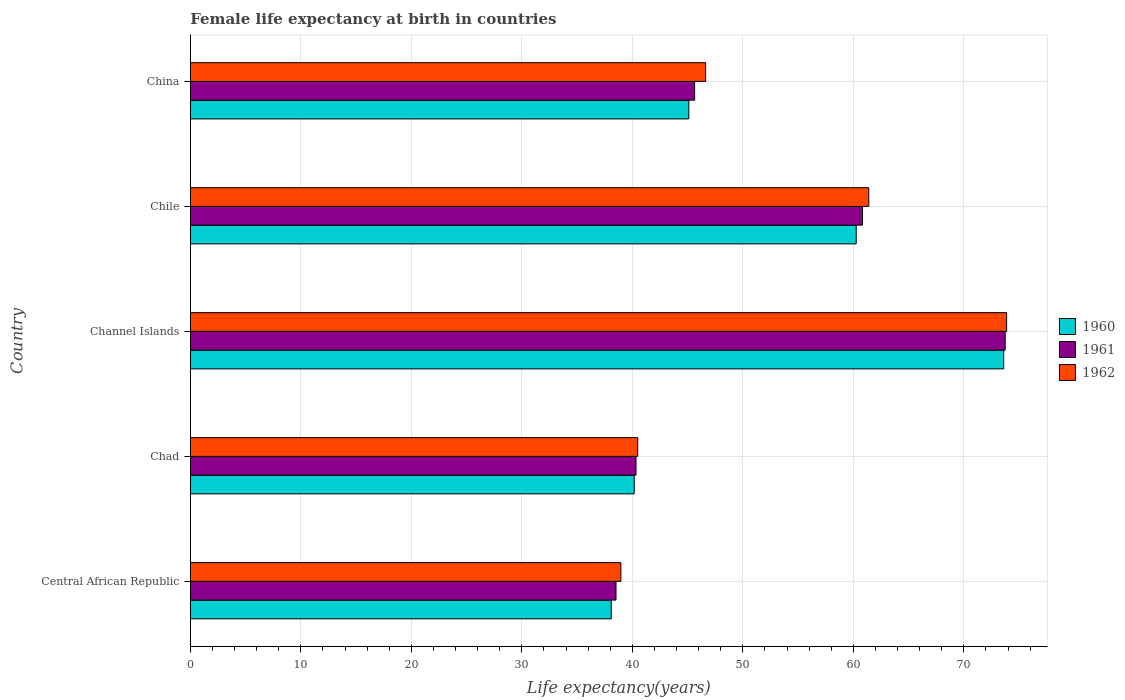How many groups of bars are there?
Your response must be concise. 5. Are the number of bars per tick equal to the number of legend labels?
Provide a short and direct response. Yes. What is the label of the 5th group of bars from the top?
Your answer should be very brief. Central African Republic. In how many cases, is the number of bars for a given country not equal to the number of legend labels?
Offer a terse response. 0. What is the female life expectancy at birth in 1961 in China?
Keep it short and to the point. 45.64. Across all countries, what is the maximum female life expectancy at birth in 1960?
Your response must be concise. 73.61. Across all countries, what is the minimum female life expectancy at birth in 1962?
Your answer should be compact. 38.97. In which country was the female life expectancy at birth in 1961 maximum?
Keep it short and to the point. Channel Islands. In which country was the female life expectancy at birth in 1961 minimum?
Make the answer very short. Central African Republic. What is the total female life expectancy at birth in 1961 in the graph?
Your response must be concise. 259.07. What is the difference between the female life expectancy at birth in 1962 in Chad and that in Chile?
Give a very brief answer. -20.91. What is the difference between the female life expectancy at birth in 1962 in China and the female life expectancy at birth in 1960 in Channel Islands?
Keep it short and to the point. -26.97. What is the average female life expectancy at birth in 1961 per country?
Offer a terse response. 51.81. What is the difference between the female life expectancy at birth in 1962 and female life expectancy at birth in 1960 in China?
Offer a very short reply. 1.53. In how many countries, is the female life expectancy at birth in 1960 greater than 6 years?
Provide a short and direct response. 5. What is the ratio of the female life expectancy at birth in 1962 in Channel Islands to that in Chile?
Your answer should be very brief. 1.2. Is the female life expectancy at birth in 1961 in Chad less than that in China?
Your answer should be very brief. Yes. What is the difference between the highest and the second highest female life expectancy at birth in 1962?
Offer a terse response. 12.47. What is the difference between the highest and the lowest female life expectancy at birth in 1962?
Offer a very short reply. 34.91. In how many countries, is the female life expectancy at birth in 1961 greater than the average female life expectancy at birth in 1961 taken over all countries?
Give a very brief answer. 2. Is the sum of the female life expectancy at birth in 1962 in Chad and Chile greater than the maximum female life expectancy at birth in 1960 across all countries?
Provide a short and direct response. Yes. What does the 1st bar from the top in Chile represents?
Your answer should be very brief. 1962. What does the 1st bar from the bottom in China represents?
Make the answer very short. 1960. Does the graph contain grids?
Provide a succinct answer. Yes. Where does the legend appear in the graph?
Provide a short and direct response. Center right. How many legend labels are there?
Your answer should be very brief. 3. What is the title of the graph?
Keep it short and to the point. Female life expectancy at birth in countries. What is the label or title of the X-axis?
Your response must be concise. Life expectancy(years). What is the label or title of the Y-axis?
Offer a terse response. Country. What is the Life expectancy(years) of 1960 in Central African Republic?
Your answer should be very brief. 38.09. What is the Life expectancy(years) in 1961 in Central African Republic?
Ensure brevity in your answer.  38.52. What is the Life expectancy(years) in 1962 in Central African Republic?
Provide a succinct answer. 38.97. What is the Life expectancy(years) of 1960 in Chad?
Your response must be concise. 40.17. What is the Life expectancy(years) in 1961 in Chad?
Provide a short and direct response. 40.33. What is the Life expectancy(years) of 1962 in Chad?
Your response must be concise. 40.49. What is the Life expectancy(years) of 1960 in Channel Islands?
Offer a terse response. 73.61. What is the Life expectancy(years) in 1961 in Channel Islands?
Keep it short and to the point. 73.74. What is the Life expectancy(years) in 1962 in Channel Islands?
Offer a terse response. 73.87. What is the Life expectancy(years) in 1960 in Chile?
Your response must be concise. 60.26. What is the Life expectancy(years) of 1961 in Chile?
Provide a short and direct response. 60.83. What is the Life expectancy(years) in 1962 in Chile?
Keep it short and to the point. 61.4. What is the Life expectancy(years) of 1960 in China?
Keep it short and to the point. 45.11. What is the Life expectancy(years) in 1961 in China?
Keep it short and to the point. 45.64. What is the Life expectancy(years) of 1962 in China?
Provide a short and direct response. 46.64. Across all countries, what is the maximum Life expectancy(years) in 1960?
Your answer should be compact. 73.61. Across all countries, what is the maximum Life expectancy(years) of 1961?
Give a very brief answer. 73.74. Across all countries, what is the maximum Life expectancy(years) of 1962?
Ensure brevity in your answer.  73.87. Across all countries, what is the minimum Life expectancy(years) in 1960?
Make the answer very short. 38.09. Across all countries, what is the minimum Life expectancy(years) of 1961?
Offer a very short reply. 38.52. Across all countries, what is the minimum Life expectancy(years) of 1962?
Your response must be concise. 38.97. What is the total Life expectancy(years) in 1960 in the graph?
Your answer should be compact. 257.25. What is the total Life expectancy(years) of 1961 in the graph?
Keep it short and to the point. 259.07. What is the total Life expectancy(years) in 1962 in the graph?
Your answer should be compact. 261.36. What is the difference between the Life expectancy(years) of 1960 in Central African Republic and that in Chad?
Provide a short and direct response. -2.08. What is the difference between the Life expectancy(years) of 1961 in Central African Republic and that in Chad?
Your response must be concise. -1.81. What is the difference between the Life expectancy(years) of 1962 in Central African Republic and that in Chad?
Ensure brevity in your answer.  -1.52. What is the difference between the Life expectancy(years) of 1960 in Central African Republic and that in Channel Islands?
Provide a succinct answer. -35.52. What is the difference between the Life expectancy(years) in 1961 in Central African Republic and that in Channel Islands?
Ensure brevity in your answer.  -35.22. What is the difference between the Life expectancy(years) of 1962 in Central African Republic and that in Channel Islands?
Ensure brevity in your answer.  -34.91. What is the difference between the Life expectancy(years) in 1960 in Central African Republic and that in Chile?
Keep it short and to the point. -22.17. What is the difference between the Life expectancy(years) of 1961 in Central African Republic and that in Chile?
Your response must be concise. -22.3. What is the difference between the Life expectancy(years) in 1962 in Central African Republic and that in Chile?
Provide a succinct answer. -22.43. What is the difference between the Life expectancy(years) in 1960 in Central African Republic and that in China?
Provide a succinct answer. -7.02. What is the difference between the Life expectancy(years) of 1961 in Central African Republic and that in China?
Offer a terse response. -7.11. What is the difference between the Life expectancy(years) of 1962 in Central African Republic and that in China?
Make the answer very short. -7.67. What is the difference between the Life expectancy(years) of 1960 in Chad and that in Channel Islands?
Your response must be concise. -33.44. What is the difference between the Life expectancy(years) in 1961 in Chad and that in Channel Islands?
Give a very brief answer. -33.41. What is the difference between the Life expectancy(years) of 1962 in Chad and that in Channel Islands?
Ensure brevity in your answer.  -33.38. What is the difference between the Life expectancy(years) in 1960 in Chad and that in Chile?
Your answer should be compact. -20.09. What is the difference between the Life expectancy(years) in 1961 in Chad and that in Chile?
Your answer should be very brief. -20.49. What is the difference between the Life expectancy(years) of 1962 in Chad and that in Chile?
Your answer should be compact. -20.91. What is the difference between the Life expectancy(years) in 1960 in Chad and that in China?
Make the answer very short. -4.94. What is the difference between the Life expectancy(years) in 1961 in Chad and that in China?
Ensure brevity in your answer.  -5.3. What is the difference between the Life expectancy(years) of 1962 in Chad and that in China?
Offer a very short reply. -6.15. What is the difference between the Life expectancy(years) of 1960 in Channel Islands and that in Chile?
Your response must be concise. 13.35. What is the difference between the Life expectancy(years) in 1961 in Channel Islands and that in Chile?
Offer a terse response. 12.91. What is the difference between the Life expectancy(years) in 1962 in Channel Islands and that in Chile?
Your response must be concise. 12.47. What is the difference between the Life expectancy(years) in 1960 in Channel Islands and that in China?
Your response must be concise. 28.5. What is the difference between the Life expectancy(years) in 1961 in Channel Islands and that in China?
Provide a short and direct response. 28.1. What is the difference between the Life expectancy(years) in 1962 in Channel Islands and that in China?
Give a very brief answer. 27.23. What is the difference between the Life expectancy(years) in 1960 in Chile and that in China?
Offer a very short reply. 15.15. What is the difference between the Life expectancy(years) in 1961 in Chile and that in China?
Your response must be concise. 15.19. What is the difference between the Life expectancy(years) in 1962 in Chile and that in China?
Offer a very short reply. 14.76. What is the difference between the Life expectancy(years) of 1960 in Central African Republic and the Life expectancy(years) of 1961 in Chad?
Offer a terse response. -2.24. What is the difference between the Life expectancy(years) of 1960 in Central African Republic and the Life expectancy(years) of 1962 in Chad?
Provide a short and direct response. -2.39. What is the difference between the Life expectancy(years) in 1961 in Central African Republic and the Life expectancy(years) in 1962 in Chad?
Ensure brevity in your answer.  -1.96. What is the difference between the Life expectancy(years) of 1960 in Central African Republic and the Life expectancy(years) of 1961 in Channel Islands?
Your answer should be very brief. -35.65. What is the difference between the Life expectancy(years) of 1960 in Central African Republic and the Life expectancy(years) of 1962 in Channel Islands?
Give a very brief answer. -35.78. What is the difference between the Life expectancy(years) of 1961 in Central African Republic and the Life expectancy(years) of 1962 in Channel Islands?
Your answer should be very brief. -35.35. What is the difference between the Life expectancy(years) of 1960 in Central African Republic and the Life expectancy(years) of 1961 in Chile?
Ensure brevity in your answer.  -22.73. What is the difference between the Life expectancy(years) of 1960 in Central African Republic and the Life expectancy(years) of 1962 in Chile?
Keep it short and to the point. -23.3. What is the difference between the Life expectancy(years) in 1961 in Central African Republic and the Life expectancy(years) in 1962 in Chile?
Offer a very short reply. -22.87. What is the difference between the Life expectancy(years) of 1960 in Central African Republic and the Life expectancy(years) of 1961 in China?
Provide a succinct answer. -7.54. What is the difference between the Life expectancy(years) in 1960 in Central African Republic and the Life expectancy(years) in 1962 in China?
Your answer should be compact. -8.54. What is the difference between the Life expectancy(years) of 1961 in Central African Republic and the Life expectancy(years) of 1962 in China?
Your response must be concise. -8.11. What is the difference between the Life expectancy(years) of 1960 in Chad and the Life expectancy(years) of 1961 in Channel Islands?
Offer a terse response. -33.57. What is the difference between the Life expectancy(years) of 1960 in Chad and the Life expectancy(years) of 1962 in Channel Islands?
Offer a terse response. -33.7. What is the difference between the Life expectancy(years) in 1961 in Chad and the Life expectancy(years) in 1962 in Channel Islands?
Keep it short and to the point. -33.54. What is the difference between the Life expectancy(years) in 1960 in Chad and the Life expectancy(years) in 1961 in Chile?
Give a very brief answer. -20.65. What is the difference between the Life expectancy(years) of 1960 in Chad and the Life expectancy(years) of 1962 in Chile?
Offer a terse response. -21.22. What is the difference between the Life expectancy(years) in 1961 in Chad and the Life expectancy(years) in 1962 in Chile?
Provide a short and direct response. -21.06. What is the difference between the Life expectancy(years) of 1960 in Chad and the Life expectancy(years) of 1961 in China?
Keep it short and to the point. -5.46. What is the difference between the Life expectancy(years) of 1960 in Chad and the Life expectancy(years) of 1962 in China?
Ensure brevity in your answer.  -6.46. What is the difference between the Life expectancy(years) of 1961 in Chad and the Life expectancy(years) of 1962 in China?
Provide a succinct answer. -6.3. What is the difference between the Life expectancy(years) in 1960 in Channel Islands and the Life expectancy(years) in 1961 in Chile?
Keep it short and to the point. 12.78. What is the difference between the Life expectancy(years) of 1960 in Channel Islands and the Life expectancy(years) of 1962 in Chile?
Keep it short and to the point. 12.21. What is the difference between the Life expectancy(years) of 1961 in Channel Islands and the Life expectancy(years) of 1962 in Chile?
Offer a very short reply. 12.34. What is the difference between the Life expectancy(years) in 1960 in Channel Islands and the Life expectancy(years) in 1961 in China?
Offer a very short reply. 27.97. What is the difference between the Life expectancy(years) of 1960 in Channel Islands and the Life expectancy(years) of 1962 in China?
Make the answer very short. 26.97. What is the difference between the Life expectancy(years) of 1961 in Channel Islands and the Life expectancy(years) of 1962 in China?
Your response must be concise. 27.1. What is the difference between the Life expectancy(years) in 1960 in Chile and the Life expectancy(years) in 1961 in China?
Provide a succinct answer. 14.62. What is the difference between the Life expectancy(years) of 1960 in Chile and the Life expectancy(years) of 1962 in China?
Offer a terse response. 13.62. What is the difference between the Life expectancy(years) in 1961 in Chile and the Life expectancy(years) in 1962 in China?
Make the answer very short. 14.19. What is the average Life expectancy(years) of 1960 per country?
Your answer should be very brief. 51.45. What is the average Life expectancy(years) in 1961 per country?
Your answer should be very brief. 51.81. What is the average Life expectancy(years) of 1962 per country?
Ensure brevity in your answer.  52.27. What is the difference between the Life expectancy(years) in 1960 and Life expectancy(years) in 1961 in Central African Republic?
Your answer should be very brief. -0.43. What is the difference between the Life expectancy(years) of 1960 and Life expectancy(years) of 1962 in Central African Republic?
Offer a terse response. -0.87. What is the difference between the Life expectancy(years) of 1961 and Life expectancy(years) of 1962 in Central African Republic?
Your answer should be compact. -0.44. What is the difference between the Life expectancy(years) in 1960 and Life expectancy(years) in 1961 in Chad?
Provide a succinct answer. -0.16. What is the difference between the Life expectancy(years) of 1960 and Life expectancy(years) of 1962 in Chad?
Offer a terse response. -0.31. What is the difference between the Life expectancy(years) of 1961 and Life expectancy(years) of 1962 in Chad?
Provide a short and direct response. -0.15. What is the difference between the Life expectancy(years) in 1960 and Life expectancy(years) in 1961 in Channel Islands?
Provide a short and direct response. -0.13. What is the difference between the Life expectancy(years) in 1960 and Life expectancy(years) in 1962 in Channel Islands?
Keep it short and to the point. -0.26. What is the difference between the Life expectancy(years) in 1961 and Life expectancy(years) in 1962 in Channel Islands?
Provide a succinct answer. -0.13. What is the difference between the Life expectancy(years) in 1960 and Life expectancy(years) in 1961 in Chile?
Offer a very short reply. -0.57. What is the difference between the Life expectancy(years) in 1960 and Life expectancy(years) in 1962 in Chile?
Offer a terse response. -1.14. What is the difference between the Life expectancy(years) in 1961 and Life expectancy(years) in 1962 in Chile?
Provide a short and direct response. -0.57. What is the difference between the Life expectancy(years) of 1960 and Life expectancy(years) of 1961 in China?
Provide a succinct answer. -0.53. What is the difference between the Life expectancy(years) of 1960 and Life expectancy(years) of 1962 in China?
Your answer should be compact. -1.53. What is the difference between the Life expectancy(years) in 1961 and Life expectancy(years) in 1962 in China?
Your response must be concise. -1. What is the ratio of the Life expectancy(years) in 1960 in Central African Republic to that in Chad?
Offer a terse response. 0.95. What is the ratio of the Life expectancy(years) of 1961 in Central African Republic to that in Chad?
Make the answer very short. 0.96. What is the ratio of the Life expectancy(years) in 1962 in Central African Republic to that in Chad?
Offer a terse response. 0.96. What is the ratio of the Life expectancy(years) of 1960 in Central African Republic to that in Channel Islands?
Your answer should be very brief. 0.52. What is the ratio of the Life expectancy(years) in 1961 in Central African Republic to that in Channel Islands?
Offer a terse response. 0.52. What is the ratio of the Life expectancy(years) in 1962 in Central African Republic to that in Channel Islands?
Ensure brevity in your answer.  0.53. What is the ratio of the Life expectancy(years) of 1960 in Central African Republic to that in Chile?
Offer a very short reply. 0.63. What is the ratio of the Life expectancy(years) in 1961 in Central African Republic to that in Chile?
Your answer should be very brief. 0.63. What is the ratio of the Life expectancy(years) of 1962 in Central African Republic to that in Chile?
Keep it short and to the point. 0.63. What is the ratio of the Life expectancy(years) in 1960 in Central African Republic to that in China?
Your answer should be very brief. 0.84. What is the ratio of the Life expectancy(years) in 1961 in Central African Republic to that in China?
Offer a terse response. 0.84. What is the ratio of the Life expectancy(years) of 1962 in Central African Republic to that in China?
Ensure brevity in your answer.  0.84. What is the ratio of the Life expectancy(years) in 1960 in Chad to that in Channel Islands?
Your answer should be very brief. 0.55. What is the ratio of the Life expectancy(years) in 1961 in Chad to that in Channel Islands?
Provide a succinct answer. 0.55. What is the ratio of the Life expectancy(years) of 1962 in Chad to that in Channel Islands?
Your answer should be very brief. 0.55. What is the ratio of the Life expectancy(years) of 1961 in Chad to that in Chile?
Make the answer very short. 0.66. What is the ratio of the Life expectancy(years) in 1962 in Chad to that in Chile?
Your answer should be very brief. 0.66. What is the ratio of the Life expectancy(years) in 1960 in Chad to that in China?
Keep it short and to the point. 0.89. What is the ratio of the Life expectancy(years) of 1961 in Chad to that in China?
Your response must be concise. 0.88. What is the ratio of the Life expectancy(years) of 1962 in Chad to that in China?
Make the answer very short. 0.87. What is the ratio of the Life expectancy(years) in 1960 in Channel Islands to that in Chile?
Ensure brevity in your answer.  1.22. What is the ratio of the Life expectancy(years) in 1961 in Channel Islands to that in Chile?
Ensure brevity in your answer.  1.21. What is the ratio of the Life expectancy(years) in 1962 in Channel Islands to that in Chile?
Provide a short and direct response. 1.2. What is the ratio of the Life expectancy(years) in 1960 in Channel Islands to that in China?
Your response must be concise. 1.63. What is the ratio of the Life expectancy(years) of 1961 in Channel Islands to that in China?
Provide a short and direct response. 1.62. What is the ratio of the Life expectancy(years) in 1962 in Channel Islands to that in China?
Your answer should be very brief. 1.58. What is the ratio of the Life expectancy(years) of 1960 in Chile to that in China?
Offer a very short reply. 1.34. What is the ratio of the Life expectancy(years) in 1961 in Chile to that in China?
Provide a short and direct response. 1.33. What is the ratio of the Life expectancy(years) of 1962 in Chile to that in China?
Keep it short and to the point. 1.32. What is the difference between the highest and the second highest Life expectancy(years) in 1960?
Provide a succinct answer. 13.35. What is the difference between the highest and the second highest Life expectancy(years) of 1961?
Your answer should be compact. 12.91. What is the difference between the highest and the second highest Life expectancy(years) of 1962?
Offer a terse response. 12.47. What is the difference between the highest and the lowest Life expectancy(years) in 1960?
Your response must be concise. 35.52. What is the difference between the highest and the lowest Life expectancy(years) in 1961?
Provide a succinct answer. 35.22. What is the difference between the highest and the lowest Life expectancy(years) in 1962?
Make the answer very short. 34.91. 